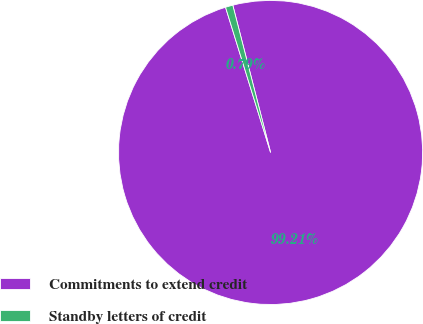Convert chart to OTSL. <chart><loc_0><loc_0><loc_500><loc_500><pie_chart><fcel>Commitments to extend credit<fcel>Standby letters of credit<nl><fcel>99.21%<fcel>0.79%<nl></chart> 